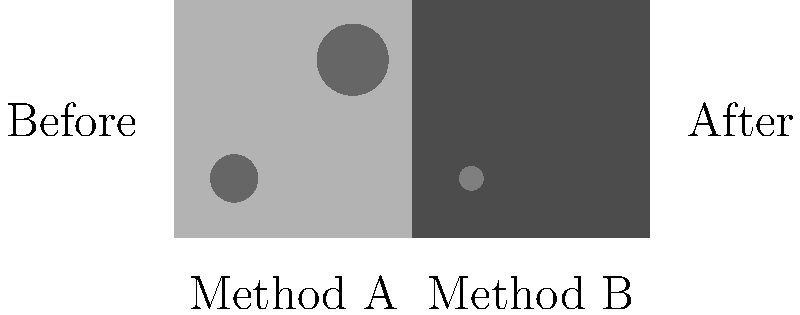Based on the before and after images of two carpet cleaning methods, which method appears to be more effective in removing dirt and stains? To determine which carpet cleaning method is more effective, we need to compare the before and after results for both methods:

1. Method A (left side):
   - Before: Two large dirt patches visible
   - After: Both dirt patches completely removed

2. Method B (right side):
   - Before: One small dirt patch visible
   - After: Small dirt patch still partially visible

3. Comparing the results:
   - Method A removed all visible dirt and stains
   - Method B left some residual dirt

4. Effectiveness assessment:
   - Method A showed complete removal of dirt
   - Method B showed partial removal of dirt

5. Conclusion:
   Based on the visual evidence, Method A appears to be more effective in removing dirt and stains from the carpet.
Answer: Method A 